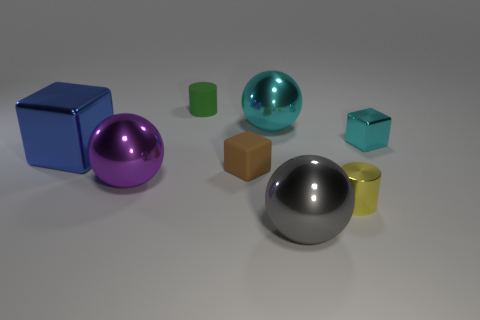What number of objects are either tiny yellow shiny things or big purple matte spheres?
Your answer should be very brief. 1. The ball that is on the left side of the cyan object that is on the left side of the big gray thing is made of what material?
Your answer should be very brief. Metal. What number of large purple objects have the same shape as the brown object?
Ensure brevity in your answer.  0. Are there any spheres of the same color as the tiny shiny block?
Give a very brief answer. Yes. What number of objects are either small blocks to the right of the big gray shiny object or small rubber objects that are in front of the big blue block?
Your answer should be compact. 2. There is a small matte object that is behind the brown thing; are there any large gray balls behind it?
Offer a terse response. No. There is a cyan thing that is the same size as the blue thing; what is its shape?
Give a very brief answer. Sphere. How many objects are either small shiny things in front of the cyan block or tiny cyan cubes?
Offer a terse response. 2. How many other objects are the same material as the tiny cyan thing?
Give a very brief answer. 5. What shape is the big thing that is the same color as the tiny metallic cube?
Make the answer very short. Sphere. 